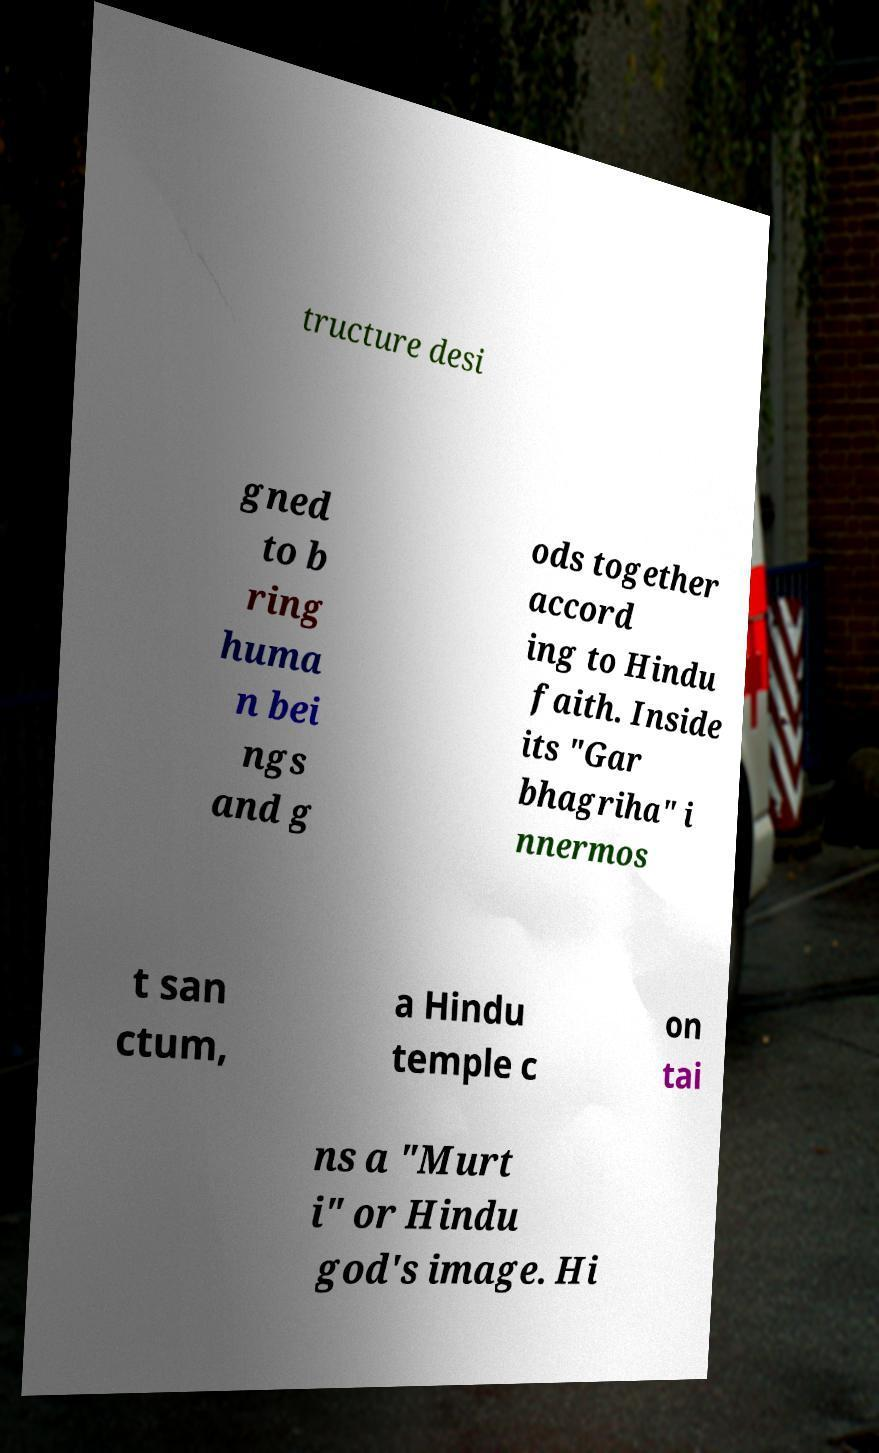For documentation purposes, I need the text within this image transcribed. Could you provide that? tructure desi gned to b ring huma n bei ngs and g ods together accord ing to Hindu faith. Inside its "Gar bhagriha" i nnermos t san ctum, a Hindu temple c on tai ns a "Murt i" or Hindu god's image. Hi 